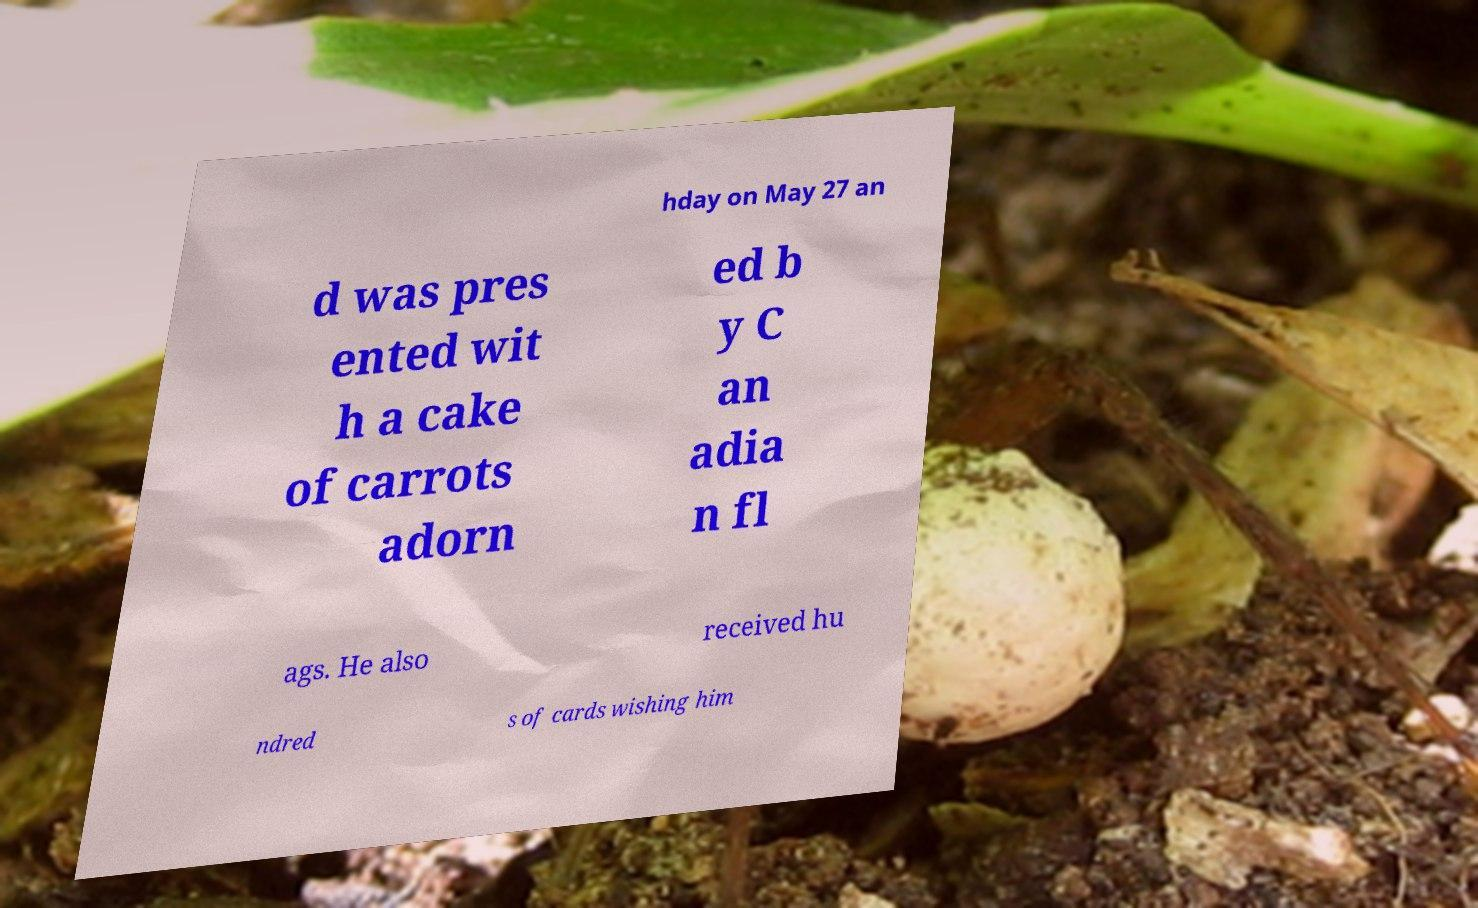Can you read and provide the text displayed in the image?This photo seems to have some interesting text. Can you extract and type it out for me? hday on May 27 an d was pres ented wit h a cake of carrots adorn ed b y C an adia n fl ags. He also received hu ndred s of cards wishing him 